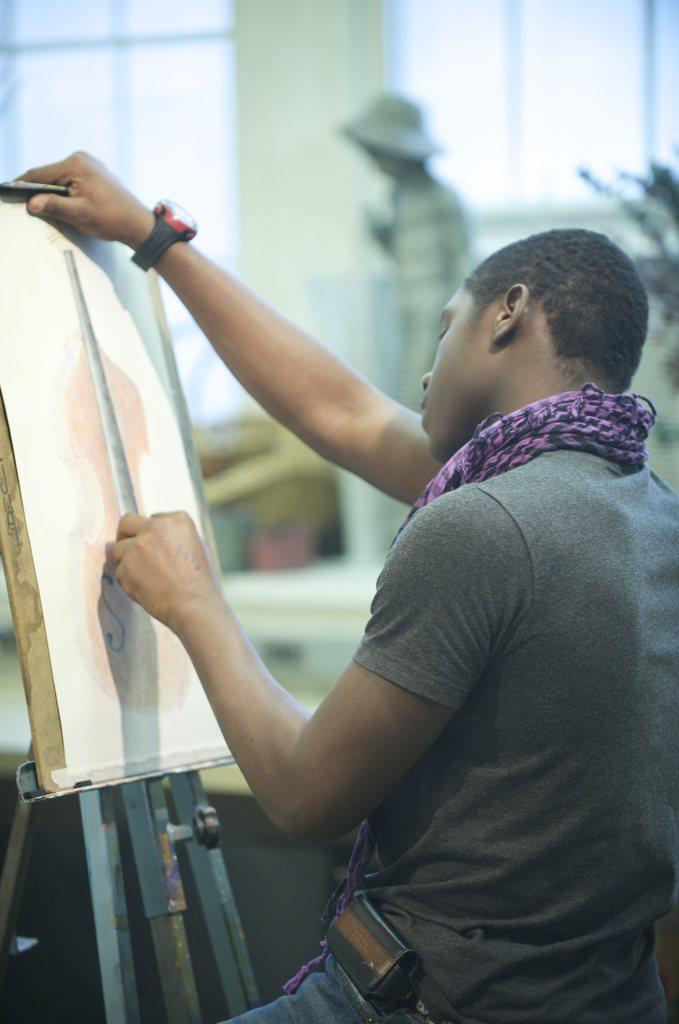What is the main subject of the image? There is a man in the image. What is the man wearing around his neck? The man is wearing a stole. What accessory is the man wearing on his wrist? The man is wearing a watch. What object is the man holding in the image? The man is holding a drawing board. What can be seen in the background of the image? There are two windows and a person with a hat in the background of the image. What is the tendency of the cattle in the image? There are no cattle present in the image. How many men are depicted in the image? The image only features one man. 